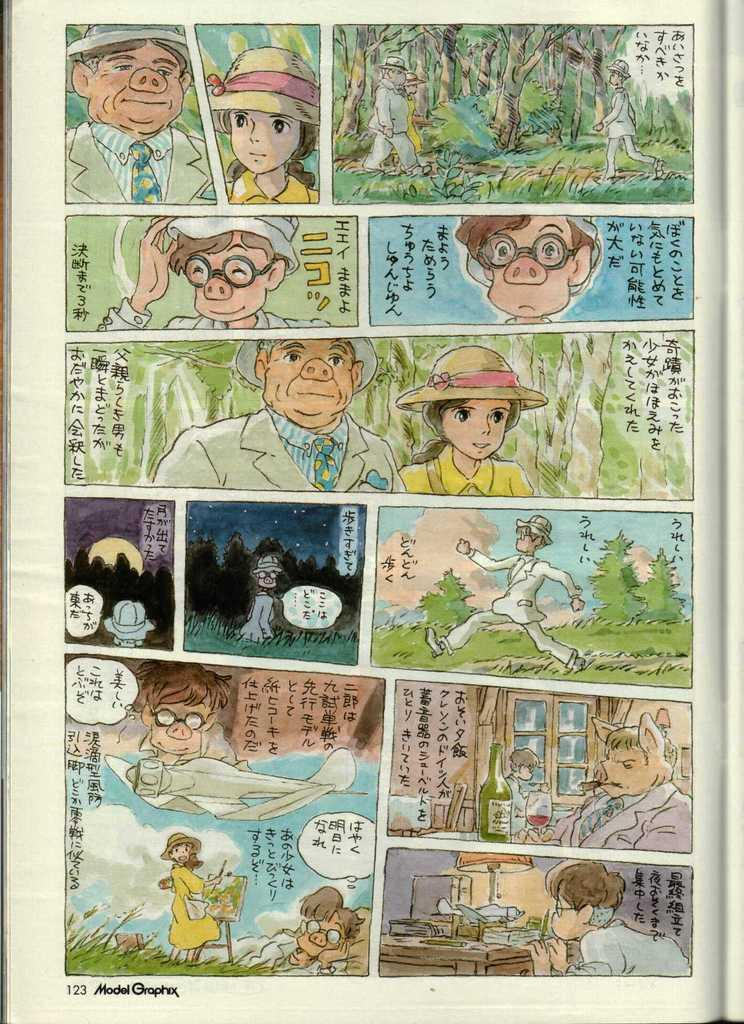What type of image is depicted in the poster? The image is a comic poster. What kind of characters can be seen on the poster? There are cartoon people on the poster. Is there any text present on the poster? Yes, there is text written on the poster. Can you tell me how many frogs are depicted on the poster? There are no frogs depicted on the poster; it features cartoon people. What type of print is used for the text on the poster? The facts do not mention the type of print used for the text on the poster, so we cannot determine that information. 